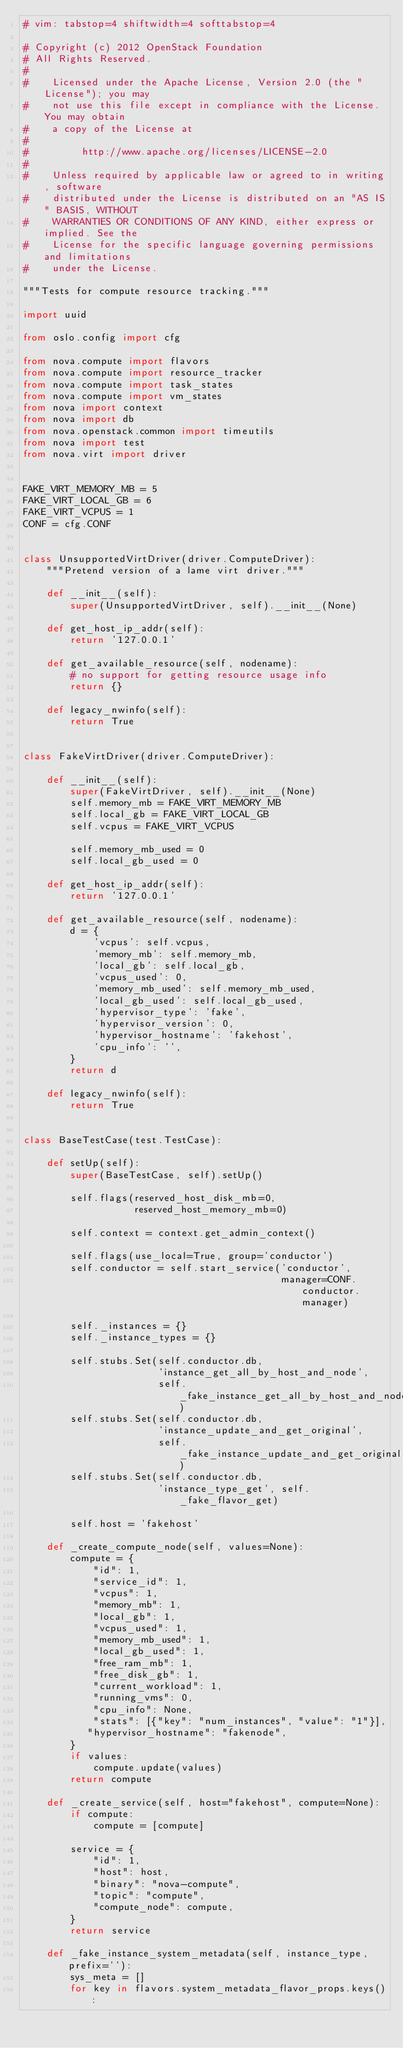<code> <loc_0><loc_0><loc_500><loc_500><_Python_># vim: tabstop=4 shiftwidth=4 softtabstop=4

# Copyright (c) 2012 OpenStack Foundation
# All Rights Reserved.
#
#    Licensed under the Apache License, Version 2.0 (the "License"); you may
#    not use this file except in compliance with the License. You may obtain
#    a copy of the License at
#
#         http://www.apache.org/licenses/LICENSE-2.0
#
#    Unless required by applicable law or agreed to in writing, software
#    distributed under the License is distributed on an "AS IS" BASIS, WITHOUT
#    WARRANTIES OR CONDITIONS OF ANY KIND, either express or implied. See the
#    License for the specific language governing permissions and limitations
#    under the License.

"""Tests for compute resource tracking."""

import uuid

from oslo.config import cfg

from nova.compute import flavors
from nova.compute import resource_tracker
from nova.compute import task_states
from nova.compute import vm_states
from nova import context
from nova import db
from nova.openstack.common import timeutils
from nova import test
from nova.virt import driver


FAKE_VIRT_MEMORY_MB = 5
FAKE_VIRT_LOCAL_GB = 6
FAKE_VIRT_VCPUS = 1
CONF = cfg.CONF


class UnsupportedVirtDriver(driver.ComputeDriver):
    """Pretend version of a lame virt driver."""

    def __init__(self):
        super(UnsupportedVirtDriver, self).__init__(None)

    def get_host_ip_addr(self):
        return '127.0.0.1'

    def get_available_resource(self, nodename):
        # no support for getting resource usage info
        return {}

    def legacy_nwinfo(self):
        return True


class FakeVirtDriver(driver.ComputeDriver):

    def __init__(self):
        super(FakeVirtDriver, self).__init__(None)
        self.memory_mb = FAKE_VIRT_MEMORY_MB
        self.local_gb = FAKE_VIRT_LOCAL_GB
        self.vcpus = FAKE_VIRT_VCPUS

        self.memory_mb_used = 0
        self.local_gb_used = 0

    def get_host_ip_addr(self):
        return '127.0.0.1'

    def get_available_resource(self, nodename):
        d = {
            'vcpus': self.vcpus,
            'memory_mb': self.memory_mb,
            'local_gb': self.local_gb,
            'vcpus_used': 0,
            'memory_mb_used': self.memory_mb_used,
            'local_gb_used': self.local_gb_used,
            'hypervisor_type': 'fake',
            'hypervisor_version': 0,
            'hypervisor_hostname': 'fakehost',
            'cpu_info': '',
        }
        return d

    def legacy_nwinfo(self):
        return True


class BaseTestCase(test.TestCase):

    def setUp(self):
        super(BaseTestCase, self).setUp()

        self.flags(reserved_host_disk_mb=0,
                   reserved_host_memory_mb=0)

        self.context = context.get_admin_context()

        self.flags(use_local=True, group='conductor')
        self.conductor = self.start_service('conductor',
                                            manager=CONF.conductor.manager)

        self._instances = {}
        self._instance_types = {}

        self.stubs.Set(self.conductor.db,
                       'instance_get_all_by_host_and_node',
                       self._fake_instance_get_all_by_host_and_node)
        self.stubs.Set(self.conductor.db,
                       'instance_update_and_get_original',
                       self._fake_instance_update_and_get_original)
        self.stubs.Set(self.conductor.db,
                       'instance_type_get', self._fake_flavor_get)

        self.host = 'fakehost'

    def _create_compute_node(self, values=None):
        compute = {
            "id": 1,
            "service_id": 1,
            "vcpus": 1,
            "memory_mb": 1,
            "local_gb": 1,
            "vcpus_used": 1,
            "memory_mb_used": 1,
            "local_gb_used": 1,
            "free_ram_mb": 1,
            "free_disk_gb": 1,
            "current_workload": 1,
            "running_vms": 0,
            "cpu_info": None,
            "stats": [{"key": "num_instances", "value": "1"}],
           "hypervisor_hostname": "fakenode",
        }
        if values:
            compute.update(values)
        return compute

    def _create_service(self, host="fakehost", compute=None):
        if compute:
            compute = [compute]

        service = {
            "id": 1,
            "host": host,
            "binary": "nova-compute",
            "topic": "compute",
            "compute_node": compute,
        }
        return service

    def _fake_instance_system_metadata(self, instance_type, prefix=''):
        sys_meta = []
        for key in flavors.system_metadata_flavor_props.keys():</code> 